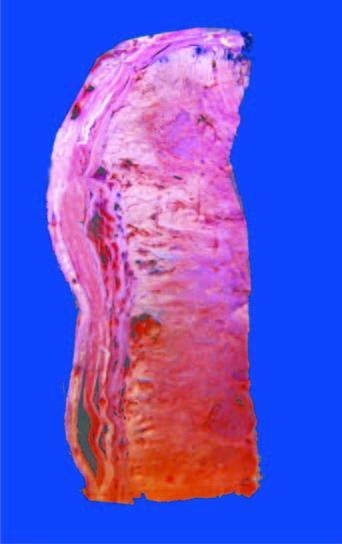s the tumour largely extending into soft tissues including the skeletal muscle?
Answer the question using a single word or phrase. Yes 